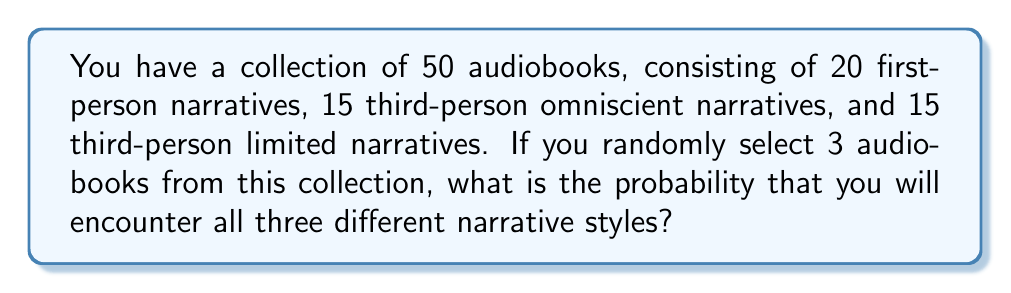Show me your answer to this math problem. Let's approach this step-by-step:

1) First, we need to calculate the total number of ways to select 3 audiobooks from 50. This is given by the combination formula:

   $$\binom{50}{3} = \frac{50!}{3!(50-3)!} = \frac{50!}{3!47!} = 19,600$$

2) Now, we need to calculate the number of ways to select one audiobook from each narrative style:
   - Ways to select a first-person narrative: 20
   - Ways to select a third-person omniscient narrative: 15
   - Ways to select a third-person limited narrative: 15

3) The total number of favorable outcomes is the product of these:

   $$20 \times 15 \times 15 = 4,500$$

4) The probability is then the number of favorable outcomes divided by the total number of possible outcomes:

   $$P(\text{all three styles}) = \frac{4,500}{19,600} = \frac{225}{980} \approx 0.2296$$

5) To express this as a percentage, we multiply by 100:

   $$0.2296 \times 100 \approx 22.96\%$$
Answer: $22.96\%$ 